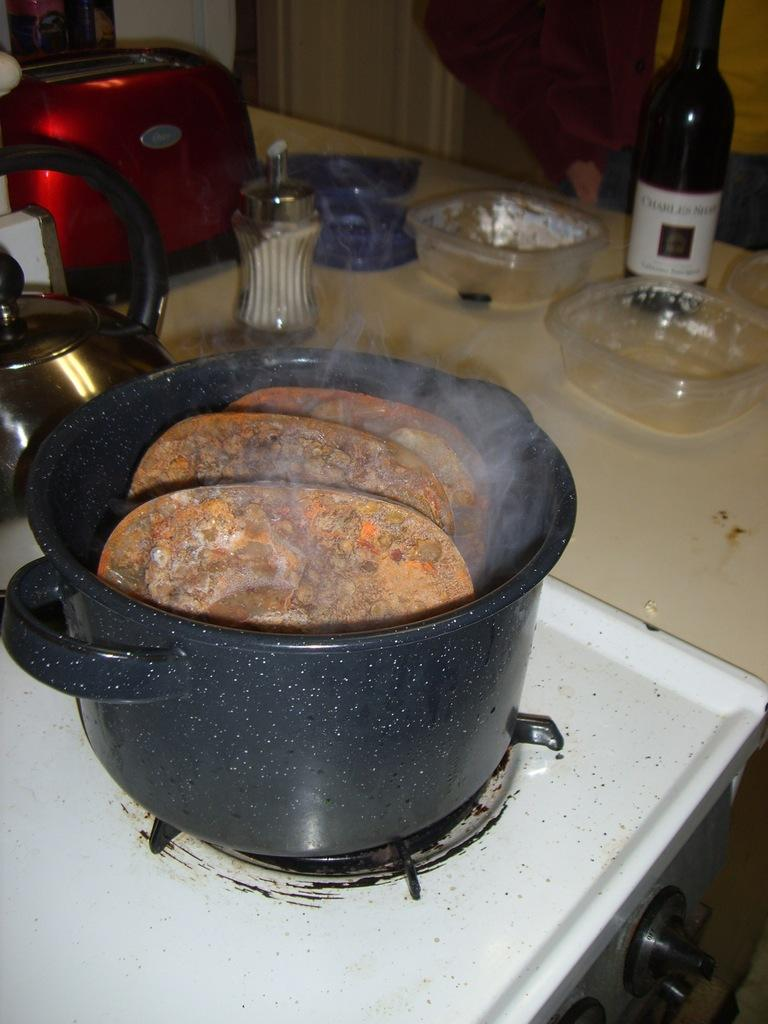What object in the image is used for holding or storing something? There is a container in the image that is used for holding or storing something. What is inside the container? There is food in the container. Where is the container located in the image? The container is on a stove. What other kitchen appliance can be seen in the image? There is a bread toaster in the image. What type of dishware is present in the image? There are bowls in the image. What type of loaf is being toasted in the bread toaster? There is no loaf present in the image; it only shows a bread toaster. Can you see any marks on the container in the image? There is no mention of any marks on the container in the provided facts, so it cannot be determined from the image. 